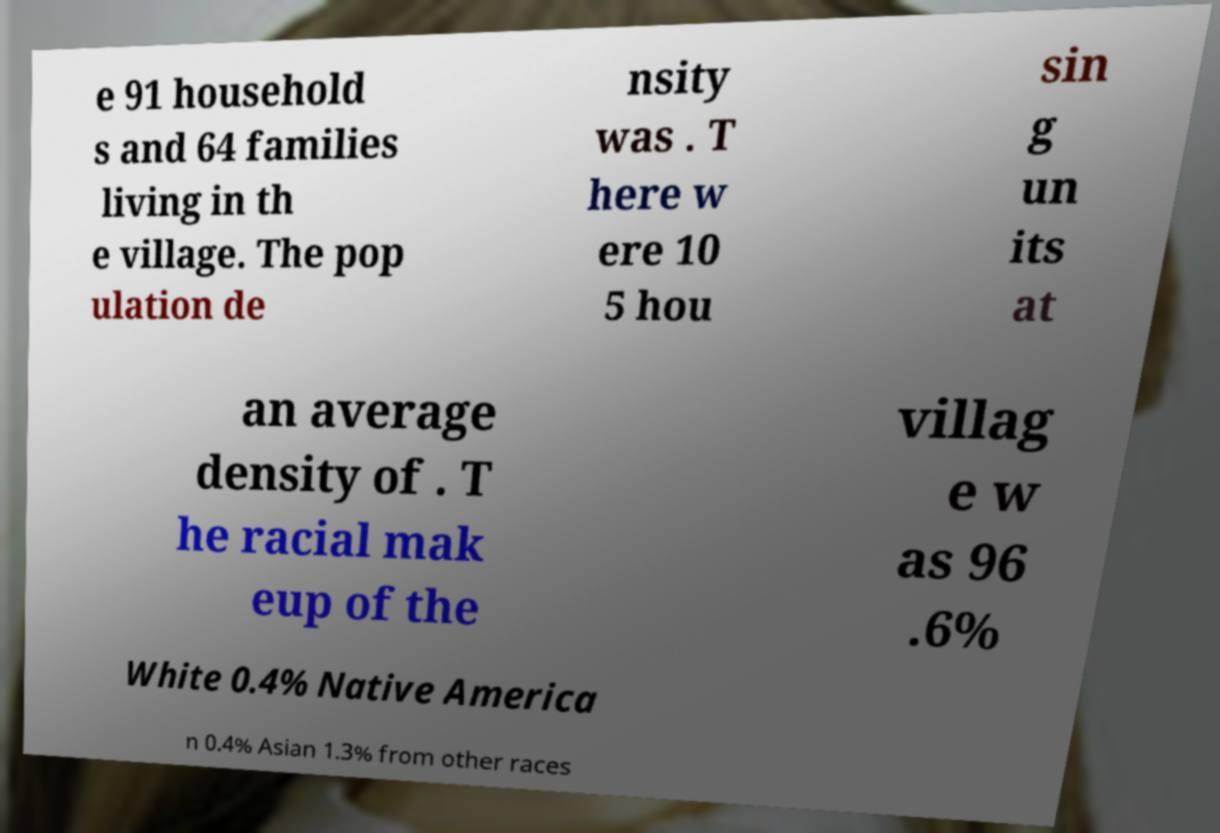Can you accurately transcribe the text from the provided image for me? e 91 household s and 64 families living in th e village. The pop ulation de nsity was . T here w ere 10 5 hou sin g un its at an average density of . T he racial mak eup of the villag e w as 96 .6% White 0.4% Native America n 0.4% Asian 1.3% from other races 